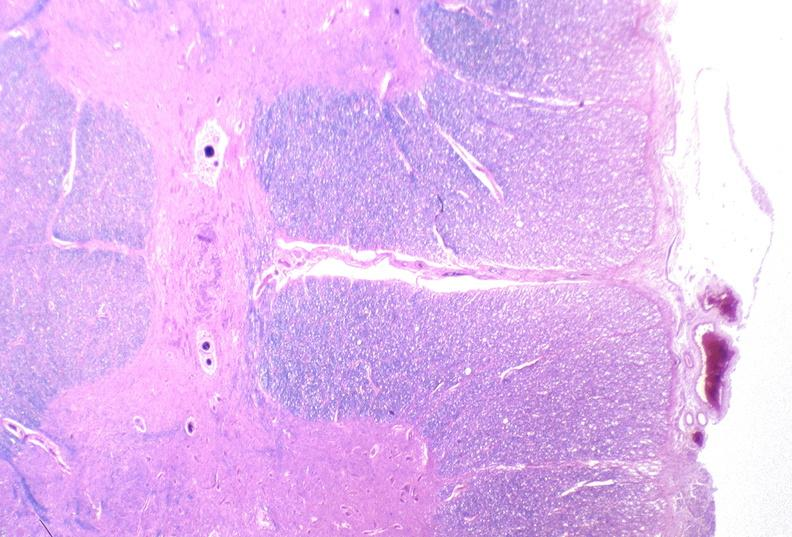what is present?
Answer the question using a single word or phrase. Nervous 